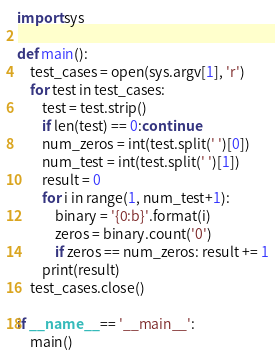Convert code to text. <code><loc_0><loc_0><loc_500><loc_500><_Python_>import sys

def main():
    test_cases = open(sys.argv[1], 'r')
    for test in test_cases:
        test = test.strip()
        if len(test) == 0:continue
        num_zeros = int(test.split(' ')[0])
        num_test = int(test.split(' ')[1])
        result = 0
        for i in range(1, num_test+1):
            binary = '{0:b}'.format(i)
            zeros = binary.count('0')
            if zeros == num_zeros: result += 1
        print(result)
    test_cases.close()

if __name__ == '__main__':
    main()</code> 